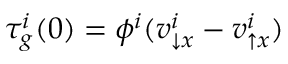<formula> <loc_0><loc_0><loc_500><loc_500>\tau _ { g } ^ { i } ( 0 ) = \phi ^ { i } ( v _ { \downarrow x } ^ { i } - v _ { \uparrow x } ^ { i } )</formula> 